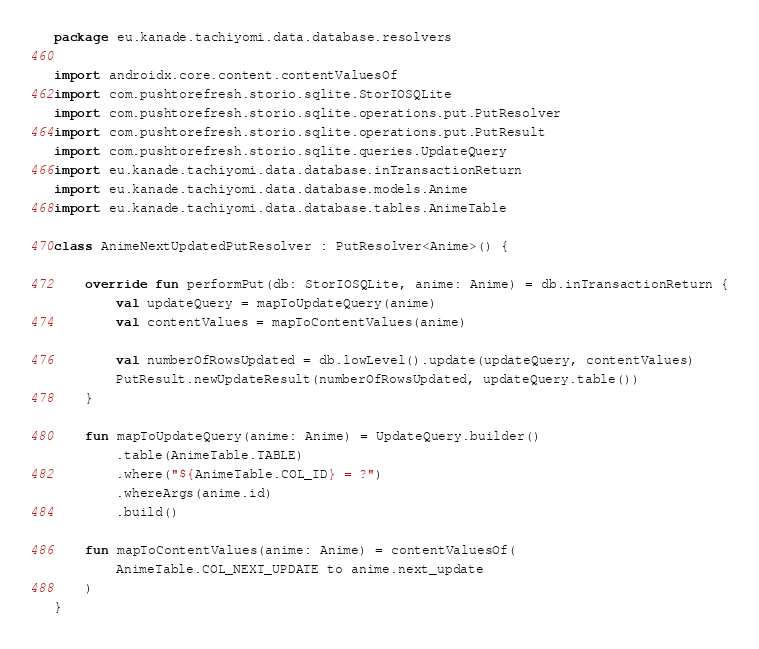<code> <loc_0><loc_0><loc_500><loc_500><_Kotlin_>package eu.kanade.tachiyomi.data.database.resolvers

import androidx.core.content.contentValuesOf
import com.pushtorefresh.storio.sqlite.StorIOSQLite
import com.pushtorefresh.storio.sqlite.operations.put.PutResolver
import com.pushtorefresh.storio.sqlite.operations.put.PutResult
import com.pushtorefresh.storio.sqlite.queries.UpdateQuery
import eu.kanade.tachiyomi.data.database.inTransactionReturn
import eu.kanade.tachiyomi.data.database.models.Anime
import eu.kanade.tachiyomi.data.database.tables.AnimeTable

class AnimeNextUpdatedPutResolver : PutResolver<Anime>() {

    override fun performPut(db: StorIOSQLite, anime: Anime) = db.inTransactionReturn {
        val updateQuery = mapToUpdateQuery(anime)
        val contentValues = mapToContentValues(anime)

        val numberOfRowsUpdated = db.lowLevel().update(updateQuery, contentValues)
        PutResult.newUpdateResult(numberOfRowsUpdated, updateQuery.table())
    }

    fun mapToUpdateQuery(anime: Anime) = UpdateQuery.builder()
        .table(AnimeTable.TABLE)
        .where("${AnimeTable.COL_ID} = ?")
        .whereArgs(anime.id)
        .build()

    fun mapToContentValues(anime: Anime) = contentValuesOf(
        AnimeTable.COL_NEXT_UPDATE to anime.next_update
    )
}
</code> 